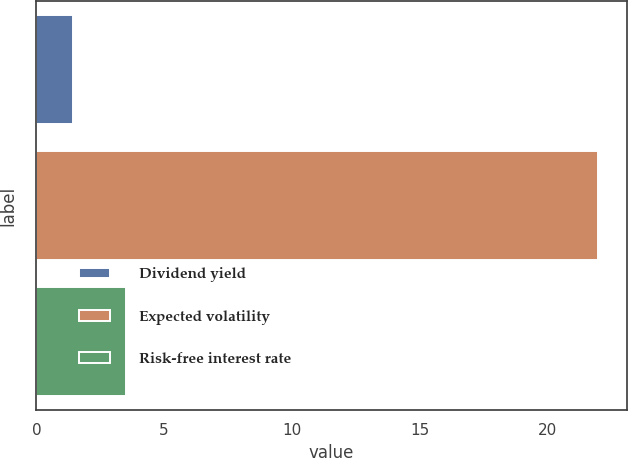<chart> <loc_0><loc_0><loc_500><loc_500><bar_chart><fcel>Dividend yield<fcel>Expected volatility<fcel>Risk-free interest rate<nl><fcel>1.45<fcel>22<fcel>3.5<nl></chart> 